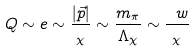Convert formula to latex. <formula><loc_0><loc_0><loc_500><loc_500>Q \sim e \sim \frac { | \vec { p } | } { \L _ { \chi } } \sim \frac { m _ { \pi } } { \Lambda _ { \chi } } \sim \frac { \ w } { \L _ { \chi } } \,</formula> 